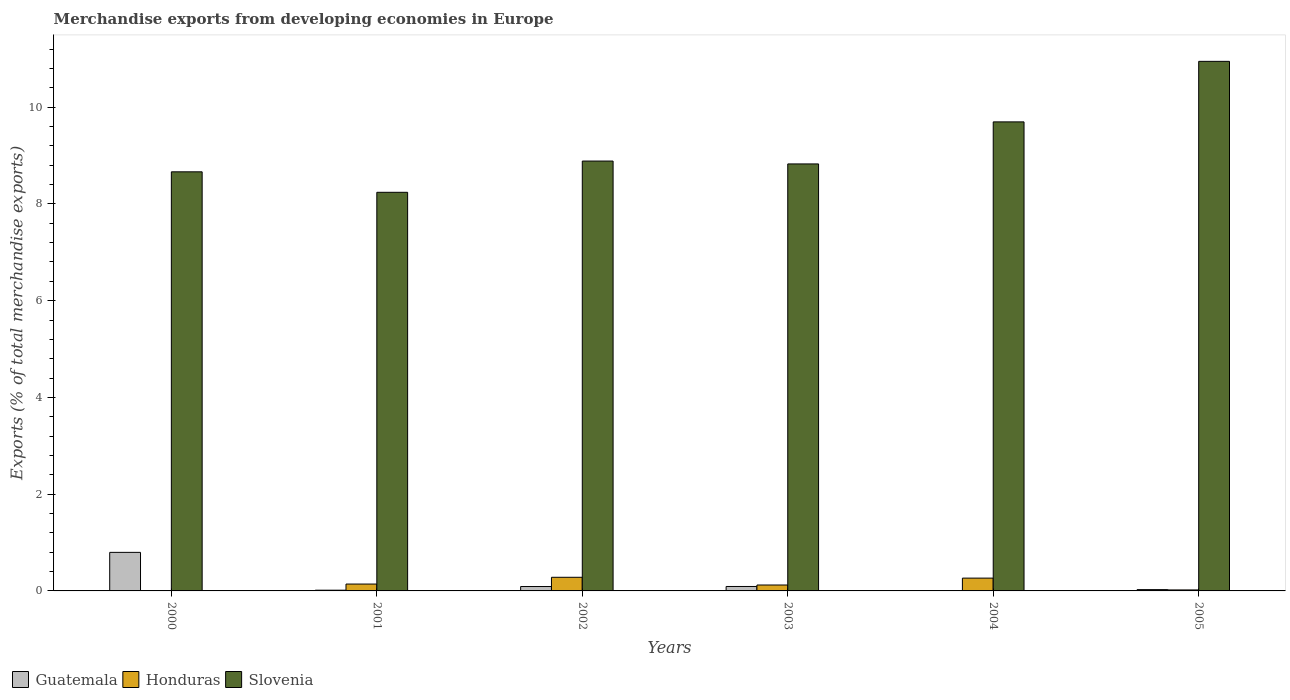How many groups of bars are there?
Offer a very short reply. 6. How many bars are there on the 3rd tick from the left?
Ensure brevity in your answer.  3. How many bars are there on the 5th tick from the right?
Make the answer very short. 3. What is the percentage of total merchandise exports in Slovenia in 2004?
Give a very brief answer. 9.7. Across all years, what is the maximum percentage of total merchandise exports in Slovenia?
Ensure brevity in your answer.  10.95. Across all years, what is the minimum percentage of total merchandise exports in Guatemala?
Your response must be concise. 0.01. What is the total percentage of total merchandise exports in Honduras in the graph?
Provide a succinct answer. 0.83. What is the difference between the percentage of total merchandise exports in Honduras in 2000 and that in 2003?
Give a very brief answer. -0.12. What is the difference between the percentage of total merchandise exports in Honduras in 2000 and the percentage of total merchandise exports in Slovenia in 2003?
Your answer should be compact. -8.82. What is the average percentage of total merchandise exports in Honduras per year?
Keep it short and to the point. 0.14. In the year 2004, what is the difference between the percentage of total merchandise exports in Honduras and percentage of total merchandise exports in Guatemala?
Ensure brevity in your answer.  0.26. What is the ratio of the percentage of total merchandise exports in Guatemala in 2001 to that in 2005?
Ensure brevity in your answer.  0.56. Is the percentage of total merchandise exports in Honduras in 2001 less than that in 2005?
Provide a succinct answer. No. Is the difference between the percentage of total merchandise exports in Honduras in 2001 and 2005 greater than the difference between the percentage of total merchandise exports in Guatemala in 2001 and 2005?
Provide a succinct answer. Yes. What is the difference between the highest and the second highest percentage of total merchandise exports in Guatemala?
Make the answer very short. 0.71. What is the difference between the highest and the lowest percentage of total merchandise exports in Guatemala?
Give a very brief answer. 0.79. Is the sum of the percentage of total merchandise exports in Honduras in 2004 and 2005 greater than the maximum percentage of total merchandise exports in Slovenia across all years?
Give a very brief answer. No. What does the 3rd bar from the left in 2000 represents?
Offer a very short reply. Slovenia. What does the 2nd bar from the right in 2004 represents?
Your answer should be compact. Honduras. How many bars are there?
Your answer should be compact. 18. Are all the bars in the graph horizontal?
Your answer should be very brief. No. How many years are there in the graph?
Offer a very short reply. 6. What is the difference between two consecutive major ticks on the Y-axis?
Make the answer very short. 2. Does the graph contain any zero values?
Offer a very short reply. No. How many legend labels are there?
Make the answer very short. 3. How are the legend labels stacked?
Offer a terse response. Horizontal. What is the title of the graph?
Provide a short and direct response. Merchandise exports from developing economies in Europe. Does "Lebanon" appear as one of the legend labels in the graph?
Ensure brevity in your answer.  No. What is the label or title of the X-axis?
Offer a very short reply. Years. What is the label or title of the Y-axis?
Provide a succinct answer. Exports (% of total merchandise exports). What is the Exports (% of total merchandise exports) of Guatemala in 2000?
Your response must be concise. 0.8. What is the Exports (% of total merchandise exports) of Honduras in 2000?
Provide a succinct answer. 0. What is the Exports (% of total merchandise exports) in Slovenia in 2000?
Keep it short and to the point. 8.66. What is the Exports (% of total merchandise exports) in Guatemala in 2001?
Keep it short and to the point. 0.02. What is the Exports (% of total merchandise exports) of Honduras in 2001?
Your response must be concise. 0.14. What is the Exports (% of total merchandise exports) in Slovenia in 2001?
Ensure brevity in your answer.  8.24. What is the Exports (% of total merchandise exports) of Guatemala in 2002?
Make the answer very short. 0.09. What is the Exports (% of total merchandise exports) of Honduras in 2002?
Provide a short and direct response. 0.28. What is the Exports (% of total merchandise exports) in Slovenia in 2002?
Offer a very short reply. 8.89. What is the Exports (% of total merchandise exports) in Guatemala in 2003?
Offer a very short reply. 0.09. What is the Exports (% of total merchandise exports) of Honduras in 2003?
Make the answer very short. 0.12. What is the Exports (% of total merchandise exports) of Slovenia in 2003?
Your answer should be compact. 8.83. What is the Exports (% of total merchandise exports) of Guatemala in 2004?
Ensure brevity in your answer.  0.01. What is the Exports (% of total merchandise exports) in Honduras in 2004?
Offer a terse response. 0.26. What is the Exports (% of total merchandise exports) in Slovenia in 2004?
Offer a very short reply. 9.7. What is the Exports (% of total merchandise exports) in Guatemala in 2005?
Your response must be concise. 0.03. What is the Exports (% of total merchandise exports) in Honduras in 2005?
Keep it short and to the point. 0.02. What is the Exports (% of total merchandise exports) in Slovenia in 2005?
Offer a terse response. 10.95. Across all years, what is the maximum Exports (% of total merchandise exports) of Guatemala?
Ensure brevity in your answer.  0.8. Across all years, what is the maximum Exports (% of total merchandise exports) in Honduras?
Your response must be concise. 0.28. Across all years, what is the maximum Exports (% of total merchandise exports) of Slovenia?
Give a very brief answer. 10.95. Across all years, what is the minimum Exports (% of total merchandise exports) in Guatemala?
Your answer should be compact. 0.01. Across all years, what is the minimum Exports (% of total merchandise exports) in Honduras?
Your answer should be compact. 0. Across all years, what is the minimum Exports (% of total merchandise exports) of Slovenia?
Provide a short and direct response. 8.24. What is the total Exports (% of total merchandise exports) in Guatemala in the graph?
Offer a terse response. 1.03. What is the total Exports (% of total merchandise exports) of Honduras in the graph?
Provide a short and direct response. 0.83. What is the total Exports (% of total merchandise exports) in Slovenia in the graph?
Provide a short and direct response. 55.26. What is the difference between the Exports (% of total merchandise exports) in Guatemala in 2000 and that in 2001?
Ensure brevity in your answer.  0.78. What is the difference between the Exports (% of total merchandise exports) of Honduras in 2000 and that in 2001?
Keep it short and to the point. -0.14. What is the difference between the Exports (% of total merchandise exports) in Slovenia in 2000 and that in 2001?
Ensure brevity in your answer.  0.42. What is the difference between the Exports (% of total merchandise exports) in Guatemala in 2000 and that in 2002?
Make the answer very short. 0.71. What is the difference between the Exports (% of total merchandise exports) of Honduras in 2000 and that in 2002?
Offer a terse response. -0.28. What is the difference between the Exports (% of total merchandise exports) in Slovenia in 2000 and that in 2002?
Ensure brevity in your answer.  -0.22. What is the difference between the Exports (% of total merchandise exports) of Guatemala in 2000 and that in 2003?
Ensure brevity in your answer.  0.71. What is the difference between the Exports (% of total merchandise exports) in Honduras in 2000 and that in 2003?
Provide a short and direct response. -0.12. What is the difference between the Exports (% of total merchandise exports) in Slovenia in 2000 and that in 2003?
Provide a short and direct response. -0.16. What is the difference between the Exports (% of total merchandise exports) in Guatemala in 2000 and that in 2004?
Make the answer very short. 0.79. What is the difference between the Exports (% of total merchandise exports) in Honduras in 2000 and that in 2004?
Your answer should be very brief. -0.26. What is the difference between the Exports (% of total merchandise exports) of Slovenia in 2000 and that in 2004?
Your response must be concise. -1.03. What is the difference between the Exports (% of total merchandise exports) of Guatemala in 2000 and that in 2005?
Offer a terse response. 0.77. What is the difference between the Exports (% of total merchandise exports) in Honduras in 2000 and that in 2005?
Provide a short and direct response. -0.02. What is the difference between the Exports (% of total merchandise exports) in Slovenia in 2000 and that in 2005?
Make the answer very short. -2.28. What is the difference between the Exports (% of total merchandise exports) of Guatemala in 2001 and that in 2002?
Provide a succinct answer. -0.08. What is the difference between the Exports (% of total merchandise exports) in Honduras in 2001 and that in 2002?
Provide a short and direct response. -0.14. What is the difference between the Exports (% of total merchandise exports) in Slovenia in 2001 and that in 2002?
Your answer should be very brief. -0.65. What is the difference between the Exports (% of total merchandise exports) of Guatemala in 2001 and that in 2003?
Provide a short and direct response. -0.08. What is the difference between the Exports (% of total merchandise exports) in Honduras in 2001 and that in 2003?
Make the answer very short. 0.02. What is the difference between the Exports (% of total merchandise exports) of Slovenia in 2001 and that in 2003?
Your answer should be compact. -0.59. What is the difference between the Exports (% of total merchandise exports) in Guatemala in 2001 and that in 2004?
Offer a terse response. 0.01. What is the difference between the Exports (% of total merchandise exports) of Honduras in 2001 and that in 2004?
Your answer should be very brief. -0.12. What is the difference between the Exports (% of total merchandise exports) of Slovenia in 2001 and that in 2004?
Provide a short and direct response. -1.46. What is the difference between the Exports (% of total merchandise exports) of Guatemala in 2001 and that in 2005?
Ensure brevity in your answer.  -0.01. What is the difference between the Exports (% of total merchandise exports) in Honduras in 2001 and that in 2005?
Give a very brief answer. 0.12. What is the difference between the Exports (% of total merchandise exports) in Slovenia in 2001 and that in 2005?
Provide a succinct answer. -2.71. What is the difference between the Exports (% of total merchandise exports) of Guatemala in 2002 and that in 2003?
Provide a succinct answer. -0. What is the difference between the Exports (% of total merchandise exports) of Honduras in 2002 and that in 2003?
Provide a succinct answer. 0.16. What is the difference between the Exports (% of total merchandise exports) in Slovenia in 2002 and that in 2003?
Keep it short and to the point. 0.06. What is the difference between the Exports (% of total merchandise exports) in Guatemala in 2002 and that in 2004?
Offer a very short reply. 0.09. What is the difference between the Exports (% of total merchandise exports) in Honduras in 2002 and that in 2004?
Provide a succinct answer. 0.02. What is the difference between the Exports (% of total merchandise exports) in Slovenia in 2002 and that in 2004?
Provide a succinct answer. -0.81. What is the difference between the Exports (% of total merchandise exports) of Guatemala in 2002 and that in 2005?
Give a very brief answer. 0.06. What is the difference between the Exports (% of total merchandise exports) in Honduras in 2002 and that in 2005?
Make the answer very short. 0.26. What is the difference between the Exports (% of total merchandise exports) in Slovenia in 2002 and that in 2005?
Give a very brief answer. -2.06. What is the difference between the Exports (% of total merchandise exports) in Guatemala in 2003 and that in 2004?
Ensure brevity in your answer.  0.09. What is the difference between the Exports (% of total merchandise exports) in Honduras in 2003 and that in 2004?
Your answer should be very brief. -0.14. What is the difference between the Exports (% of total merchandise exports) of Slovenia in 2003 and that in 2004?
Your answer should be very brief. -0.87. What is the difference between the Exports (% of total merchandise exports) of Guatemala in 2003 and that in 2005?
Your response must be concise. 0.06. What is the difference between the Exports (% of total merchandise exports) of Honduras in 2003 and that in 2005?
Ensure brevity in your answer.  0.1. What is the difference between the Exports (% of total merchandise exports) of Slovenia in 2003 and that in 2005?
Your answer should be very brief. -2.12. What is the difference between the Exports (% of total merchandise exports) in Guatemala in 2004 and that in 2005?
Give a very brief answer. -0.02. What is the difference between the Exports (% of total merchandise exports) in Honduras in 2004 and that in 2005?
Provide a succinct answer. 0.24. What is the difference between the Exports (% of total merchandise exports) in Slovenia in 2004 and that in 2005?
Your answer should be compact. -1.25. What is the difference between the Exports (% of total merchandise exports) in Guatemala in 2000 and the Exports (% of total merchandise exports) in Honduras in 2001?
Give a very brief answer. 0.66. What is the difference between the Exports (% of total merchandise exports) in Guatemala in 2000 and the Exports (% of total merchandise exports) in Slovenia in 2001?
Offer a very short reply. -7.44. What is the difference between the Exports (% of total merchandise exports) of Honduras in 2000 and the Exports (% of total merchandise exports) of Slovenia in 2001?
Your response must be concise. -8.24. What is the difference between the Exports (% of total merchandise exports) in Guatemala in 2000 and the Exports (% of total merchandise exports) in Honduras in 2002?
Provide a short and direct response. 0.52. What is the difference between the Exports (% of total merchandise exports) of Guatemala in 2000 and the Exports (% of total merchandise exports) of Slovenia in 2002?
Your answer should be compact. -8.09. What is the difference between the Exports (% of total merchandise exports) in Honduras in 2000 and the Exports (% of total merchandise exports) in Slovenia in 2002?
Offer a terse response. -8.88. What is the difference between the Exports (% of total merchandise exports) of Guatemala in 2000 and the Exports (% of total merchandise exports) of Honduras in 2003?
Your answer should be compact. 0.67. What is the difference between the Exports (% of total merchandise exports) in Guatemala in 2000 and the Exports (% of total merchandise exports) in Slovenia in 2003?
Offer a terse response. -8.03. What is the difference between the Exports (% of total merchandise exports) in Honduras in 2000 and the Exports (% of total merchandise exports) in Slovenia in 2003?
Your response must be concise. -8.82. What is the difference between the Exports (% of total merchandise exports) in Guatemala in 2000 and the Exports (% of total merchandise exports) in Honduras in 2004?
Give a very brief answer. 0.53. What is the difference between the Exports (% of total merchandise exports) of Guatemala in 2000 and the Exports (% of total merchandise exports) of Slovenia in 2004?
Provide a short and direct response. -8.9. What is the difference between the Exports (% of total merchandise exports) of Honduras in 2000 and the Exports (% of total merchandise exports) of Slovenia in 2004?
Offer a terse response. -9.69. What is the difference between the Exports (% of total merchandise exports) in Guatemala in 2000 and the Exports (% of total merchandise exports) in Honduras in 2005?
Offer a terse response. 0.78. What is the difference between the Exports (% of total merchandise exports) of Guatemala in 2000 and the Exports (% of total merchandise exports) of Slovenia in 2005?
Your answer should be compact. -10.15. What is the difference between the Exports (% of total merchandise exports) in Honduras in 2000 and the Exports (% of total merchandise exports) in Slovenia in 2005?
Make the answer very short. -10.94. What is the difference between the Exports (% of total merchandise exports) in Guatemala in 2001 and the Exports (% of total merchandise exports) in Honduras in 2002?
Ensure brevity in your answer.  -0.27. What is the difference between the Exports (% of total merchandise exports) of Guatemala in 2001 and the Exports (% of total merchandise exports) of Slovenia in 2002?
Provide a short and direct response. -8.87. What is the difference between the Exports (% of total merchandise exports) in Honduras in 2001 and the Exports (% of total merchandise exports) in Slovenia in 2002?
Your answer should be compact. -8.74. What is the difference between the Exports (% of total merchandise exports) in Guatemala in 2001 and the Exports (% of total merchandise exports) in Honduras in 2003?
Offer a terse response. -0.11. What is the difference between the Exports (% of total merchandise exports) in Guatemala in 2001 and the Exports (% of total merchandise exports) in Slovenia in 2003?
Your response must be concise. -8.81. What is the difference between the Exports (% of total merchandise exports) of Honduras in 2001 and the Exports (% of total merchandise exports) of Slovenia in 2003?
Make the answer very short. -8.68. What is the difference between the Exports (% of total merchandise exports) of Guatemala in 2001 and the Exports (% of total merchandise exports) of Honduras in 2004?
Make the answer very short. -0.25. What is the difference between the Exports (% of total merchandise exports) of Guatemala in 2001 and the Exports (% of total merchandise exports) of Slovenia in 2004?
Give a very brief answer. -9.68. What is the difference between the Exports (% of total merchandise exports) of Honduras in 2001 and the Exports (% of total merchandise exports) of Slovenia in 2004?
Provide a succinct answer. -9.55. What is the difference between the Exports (% of total merchandise exports) of Guatemala in 2001 and the Exports (% of total merchandise exports) of Honduras in 2005?
Give a very brief answer. -0.01. What is the difference between the Exports (% of total merchandise exports) of Guatemala in 2001 and the Exports (% of total merchandise exports) of Slovenia in 2005?
Give a very brief answer. -10.93. What is the difference between the Exports (% of total merchandise exports) of Honduras in 2001 and the Exports (% of total merchandise exports) of Slovenia in 2005?
Your answer should be very brief. -10.8. What is the difference between the Exports (% of total merchandise exports) in Guatemala in 2002 and the Exports (% of total merchandise exports) in Honduras in 2003?
Keep it short and to the point. -0.03. What is the difference between the Exports (% of total merchandise exports) of Guatemala in 2002 and the Exports (% of total merchandise exports) of Slovenia in 2003?
Give a very brief answer. -8.74. What is the difference between the Exports (% of total merchandise exports) of Honduras in 2002 and the Exports (% of total merchandise exports) of Slovenia in 2003?
Ensure brevity in your answer.  -8.54. What is the difference between the Exports (% of total merchandise exports) in Guatemala in 2002 and the Exports (% of total merchandise exports) in Honduras in 2004?
Make the answer very short. -0.17. What is the difference between the Exports (% of total merchandise exports) in Guatemala in 2002 and the Exports (% of total merchandise exports) in Slovenia in 2004?
Keep it short and to the point. -9.6. What is the difference between the Exports (% of total merchandise exports) in Honduras in 2002 and the Exports (% of total merchandise exports) in Slovenia in 2004?
Your response must be concise. -9.41. What is the difference between the Exports (% of total merchandise exports) in Guatemala in 2002 and the Exports (% of total merchandise exports) in Honduras in 2005?
Your response must be concise. 0.07. What is the difference between the Exports (% of total merchandise exports) in Guatemala in 2002 and the Exports (% of total merchandise exports) in Slovenia in 2005?
Ensure brevity in your answer.  -10.86. What is the difference between the Exports (% of total merchandise exports) in Honduras in 2002 and the Exports (% of total merchandise exports) in Slovenia in 2005?
Provide a succinct answer. -10.66. What is the difference between the Exports (% of total merchandise exports) in Guatemala in 2003 and the Exports (% of total merchandise exports) in Honduras in 2004?
Make the answer very short. -0.17. What is the difference between the Exports (% of total merchandise exports) in Guatemala in 2003 and the Exports (% of total merchandise exports) in Slovenia in 2004?
Offer a very short reply. -9.6. What is the difference between the Exports (% of total merchandise exports) in Honduras in 2003 and the Exports (% of total merchandise exports) in Slovenia in 2004?
Your answer should be very brief. -9.57. What is the difference between the Exports (% of total merchandise exports) in Guatemala in 2003 and the Exports (% of total merchandise exports) in Honduras in 2005?
Offer a terse response. 0.07. What is the difference between the Exports (% of total merchandise exports) of Guatemala in 2003 and the Exports (% of total merchandise exports) of Slovenia in 2005?
Provide a short and direct response. -10.85. What is the difference between the Exports (% of total merchandise exports) of Honduras in 2003 and the Exports (% of total merchandise exports) of Slovenia in 2005?
Your response must be concise. -10.82. What is the difference between the Exports (% of total merchandise exports) of Guatemala in 2004 and the Exports (% of total merchandise exports) of Honduras in 2005?
Keep it short and to the point. -0.02. What is the difference between the Exports (% of total merchandise exports) of Guatemala in 2004 and the Exports (% of total merchandise exports) of Slovenia in 2005?
Provide a succinct answer. -10.94. What is the difference between the Exports (% of total merchandise exports) in Honduras in 2004 and the Exports (% of total merchandise exports) in Slovenia in 2005?
Your response must be concise. -10.68. What is the average Exports (% of total merchandise exports) of Guatemala per year?
Offer a terse response. 0.17. What is the average Exports (% of total merchandise exports) of Honduras per year?
Provide a succinct answer. 0.14. What is the average Exports (% of total merchandise exports) in Slovenia per year?
Your response must be concise. 9.21. In the year 2000, what is the difference between the Exports (% of total merchandise exports) in Guatemala and Exports (% of total merchandise exports) in Honduras?
Offer a terse response. 0.79. In the year 2000, what is the difference between the Exports (% of total merchandise exports) of Guatemala and Exports (% of total merchandise exports) of Slovenia?
Provide a succinct answer. -7.87. In the year 2000, what is the difference between the Exports (% of total merchandise exports) in Honduras and Exports (% of total merchandise exports) in Slovenia?
Your answer should be very brief. -8.66. In the year 2001, what is the difference between the Exports (% of total merchandise exports) in Guatemala and Exports (% of total merchandise exports) in Honduras?
Provide a succinct answer. -0.13. In the year 2001, what is the difference between the Exports (% of total merchandise exports) in Guatemala and Exports (% of total merchandise exports) in Slovenia?
Make the answer very short. -8.22. In the year 2001, what is the difference between the Exports (% of total merchandise exports) of Honduras and Exports (% of total merchandise exports) of Slovenia?
Make the answer very short. -8.1. In the year 2002, what is the difference between the Exports (% of total merchandise exports) in Guatemala and Exports (% of total merchandise exports) in Honduras?
Offer a very short reply. -0.19. In the year 2002, what is the difference between the Exports (% of total merchandise exports) of Guatemala and Exports (% of total merchandise exports) of Slovenia?
Provide a succinct answer. -8.79. In the year 2002, what is the difference between the Exports (% of total merchandise exports) of Honduras and Exports (% of total merchandise exports) of Slovenia?
Offer a terse response. -8.6. In the year 2003, what is the difference between the Exports (% of total merchandise exports) of Guatemala and Exports (% of total merchandise exports) of Honduras?
Provide a succinct answer. -0.03. In the year 2003, what is the difference between the Exports (% of total merchandise exports) in Guatemala and Exports (% of total merchandise exports) in Slovenia?
Ensure brevity in your answer.  -8.73. In the year 2003, what is the difference between the Exports (% of total merchandise exports) of Honduras and Exports (% of total merchandise exports) of Slovenia?
Your response must be concise. -8.7. In the year 2004, what is the difference between the Exports (% of total merchandise exports) in Guatemala and Exports (% of total merchandise exports) in Honduras?
Make the answer very short. -0.26. In the year 2004, what is the difference between the Exports (% of total merchandise exports) of Guatemala and Exports (% of total merchandise exports) of Slovenia?
Provide a succinct answer. -9.69. In the year 2004, what is the difference between the Exports (% of total merchandise exports) in Honduras and Exports (% of total merchandise exports) in Slovenia?
Offer a very short reply. -9.43. In the year 2005, what is the difference between the Exports (% of total merchandise exports) of Guatemala and Exports (% of total merchandise exports) of Honduras?
Offer a terse response. 0.01. In the year 2005, what is the difference between the Exports (% of total merchandise exports) of Guatemala and Exports (% of total merchandise exports) of Slovenia?
Offer a very short reply. -10.92. In the year 2005, what is the difference between the Exports (% of total merchandise exports) in Honduras and Exports (% of total merchandise exports) in Slovenia?
Offer a terse response. -10.93. What is the ratio of the Exports (% of total merchandise exports) in Guatemala in 2000 to that in 2001?
Ensure brevity in your answer.  52.81. What is the ratio of the Exports (% of total merchandise exports) of Honduras in 2000 to that in 2001?
Offer a terse response. 0.02. What is the ratio of the Exports (% of total merchandise exports) of Slovenia in 2000 to that in 2001?
Make the answer very short. 1.05. What is the ratio of the Exports (% of total merchandise exports) in Guatemala in 2000 to that in 2002?
Offer a terse response. 8.78. What is the ratio of the Exports (% of total merchandise exports) of Honduras in 2000 to that in 2002?
Keep it short and to the point. 0.01. What is the ratio of the Exports (% of total merchandise exports) in Slovenia in 2000 to that in 2002?
Keep it short and to the point. 0.97. What is the ratio of the Exports (% of total merchandise exports) in Guatemala in 2000 to that in 2003?
Provide a short and direct response. 8.68. What is the ratio of the Exports (% of total merchandise exports) of Honduras in 2000 to that in 2003?
Make the answer very short. 0.02. What is the ratio of the Exports (% of total merchandise exports) of Slovenia in 2000 to that in 2003?
Offer a very short reply. 0.98. What is the ratio of the Exports (% of total merchandise exports) in Guatemala in 2000 to that in 2004?
Ensure brevity in your answer.  151.38. What is the ratio of the Exports (% of total merchandise exports) in Honduras in 2000 to that in 2004?
Offer a terse response. 0.01. What is the ratio of the Exports (% of total merchandise exports) of Slovenia in 2000 to that in 2004?
Provide a succinct answer. 0.89. What is the ratio of the Exports (% of total merchandise exports) of Guatemala in 2000 to that in 2005?
Your response must be concise. 29.54. What is the ratio of the Exports (% of total merchandise exports) in Honduras in 2000 to that in 2005?
Provide a succinct answer. 0.14. What is the ratio of the Exports (% of total merchandise exports) in Slovenia in 2000 to that in 2005?
Offer a terse response. 0.79. What is the ratio of the Exports (% of total merchandise exports) of Guatemala in 2001 to that in 2002?
Your answer should be compact. 0.17. What is the ratio of the Exports (% of total merchandise exports) of Honduras in 2001 to that in 2002?
Offer a terse response. 0.5. What is the ratio of the Exports (% of total merchandise exports) in Slovenia in 2001 to that in 2002?
Provide a succinct answer. 0.93. What is the ratio of the Exports (% of total merchandise exports) of Guatemala in 2001 to that in 2003?
Provide a short and direct response. 0.16. What is the ratio of the Exports (% of total merchandise exports) of Honduras in 2001 to that in 2003?
Provide a short and direct response. 1.16. What is the ratio of the Exports (% of total merchandise exports) in Slovenia in 2001 to that in 2003?
Ensure brevity in your answer.  0.93. What is the ratio of the Exports (% of total merchandise exports) of Guatemala in 2001 to that in 2004?
Offer a terse response. 2.87. What is the ratio of the Exports (% of total merchandise exports) in Honduras in 2001 to that in 2004?
Your answer should be compact. 0.54. What is the ratio of the Exports (% of total merchandise exports) of Slovenia in 2001 to that in 2004?
Provide a short and direct response. 0.85. What is the ratio of the Exports (% of total merchandise exports) in Guatemala in 2001 to that in 2005?
Your answer should be very brief. 0.56. What is the ratio of the Exports (% of total merchandise exports) of Honduras in 2001 to that in 2005?
Keep it short and to the point. 6.95. What is the ratio of the Exports (% of total merchandise exports) in Slovenia in 2001 to that in 2005?
Provide a succinct answer. 0.75. What is the ratio of the Exports (% of total merchandise exports) in Guatemala in 2002 to that in 2003?
Your response must be concise. 0.99. What is the ratio of the Exports (% of total merchandise exports) of Honduras in 2002 to that in 2003?
Ensure brevity in your answer.  2.3. What is the ratio of the Exports (% of total merchandise exports) in Slovenia in 2002 to that in 2003?
Provide a short and direct response. 1.01. What is the ratio of the Exports (% of total merchandise exports) of Guatemala in 2002 to that in 2004?
Offer a very short reply. 17.24. What is the ratio of the Exports (% of total merchandise exports) in Honduras in 2002 to that in 2004?
Give a very brief answer. 1.06. What is the ratio of the Exports (% of total merchandise exports) of Slovenia in 2002 to that in 2004?
Your response must be concise. 0.92. What is the ratio of the Exports (% of total merchandise exports) of Guatemala in 2002 to that in 2005?
Your answer should be very brief. 3.36. What is the ratio of the Exports (% of total merchandise exports) of Honduras in 2002 to that in 2005?
Offer a terse response. 13.8. What is the ratio of the Exports (% of total merchandise exports) of Slovenia in 2002 to that in 2005?
Your answer should be compact. 0.81. What is the ratio of the Exports (% of total merchandise exports) of Guatemala in 2003 to that in 2004?
Offer a terse response. 17.44. What is the ratio of the Exports (% of total merchandise exports) of Honduras in 2003 to that in 2004?
Make the answer very short. 0.46. What is the ratio of the Exports (% of total merchandise exports) in Slovenia in 2003 to that in 2004?
Offer a terse response. 0.91. What is the ratio of the Exports (% of total merchandise exports) in Guatemala in 2003 to that in 2005?
Your response must be concise. 3.4. What is the ratio of the Exports (% of total merchandise exports) in Honduras in 2003 to that in 2005?
Offer a terse response. 5.99. What is the ratio of the Exports (% of total merchandise exports) in Slovenia in 2003 to that in 2005?
Your response must be concise. 0.81. What is the ratio of the Exports (% of total merchandise exports) in Guatemala in 2004 to that in 2005?
Your response must be concise. 0.2. What is the ratio of the Exports (% of total merchandise exports) of Honduras in 2004 to that in 2005?
Make the answer very short. 12.97. What is the ratio of the Exports (% of total merchandise exports) of Slovenia in 2004 to that in 2005?
Your answer should be very brief. 0.89. What is the difference between the highest and the second highest Exports (% of total merchandise exports) in Guatemala?
Your response must be concise. 0.71. What is the difference between the highest and the second highest Exports (% of total merchandise exports) in Honduras?
Ensure brevity in your answer.  0.02. What is the difference between the highest and the second highest Exports (% of total merchandise exports) of Slovenia?
Your answer should be compact. 1.25. What is the difference between the highest and the lowest Exports (% of total merchandise exports) in Guatemala?
Ensure brevity in your answer.  0.79. What is the difference between the highest and the lowest Exports (% of total merchandise exports) of Honduras?
Provide a succinct answer. 0.28. What is the difference between the highest and the lowest Exports (% of total merchandise exports) of Slovenia?
Keep it short and to the point. 2.71. 